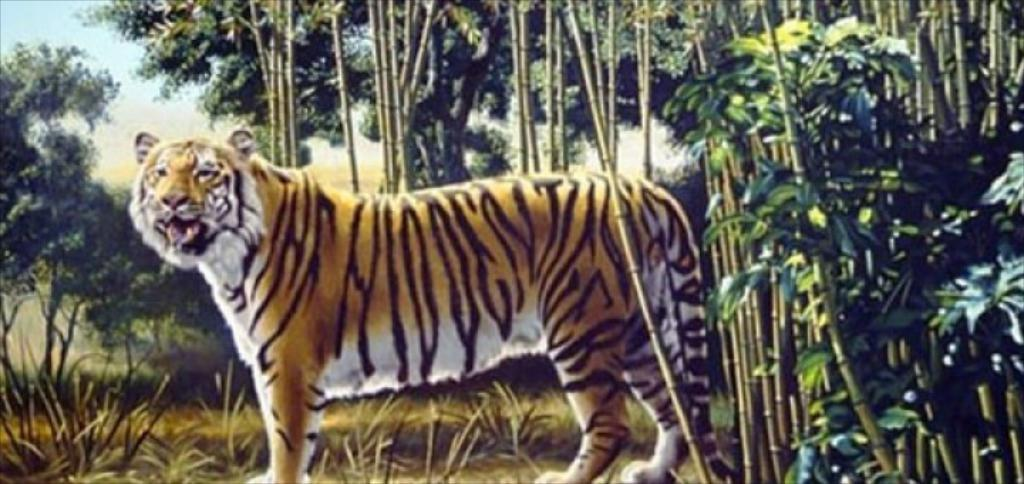What is the main subject of the image? There is a painting in the image. What is depicted in the painting? The painting contains a tiger. What can be seen in the background of the painting? There are plants and trees behind the tiger in the painting. What type of treatment is the tiger receiving in the image? There is no indication in the image that the tiger is receiving any treatment. What kind of quilt is covering the tiger in the image? There is no quilt present in the image; it is a painting of a tiger with plants and trees in the background. 